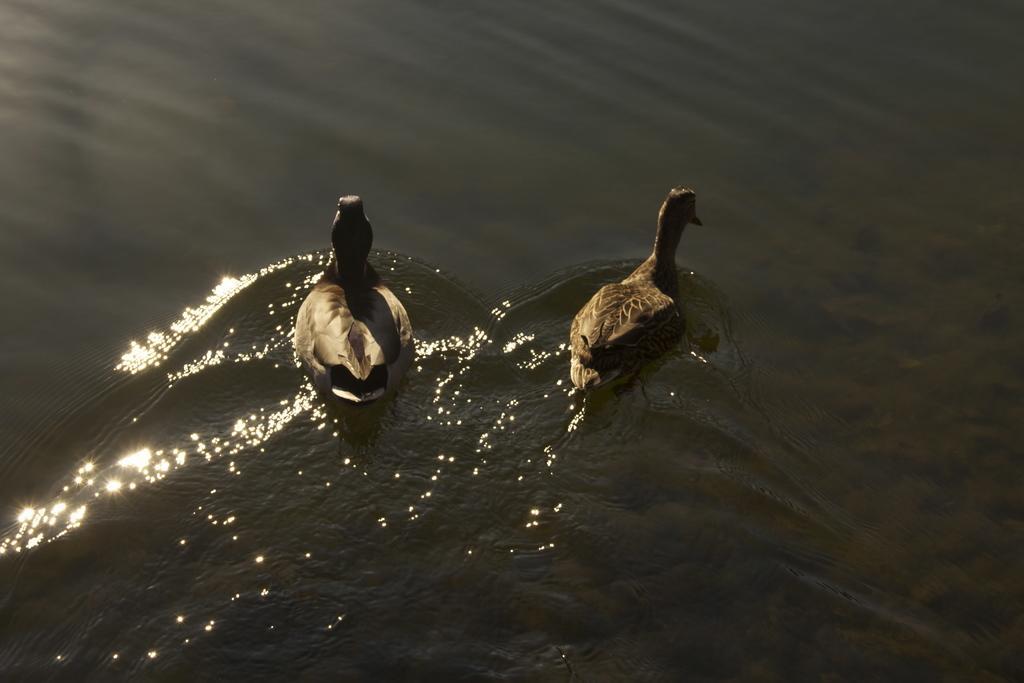Describe this image in one or two sentences. In this image, we can see two ducks that are floating on the water. 